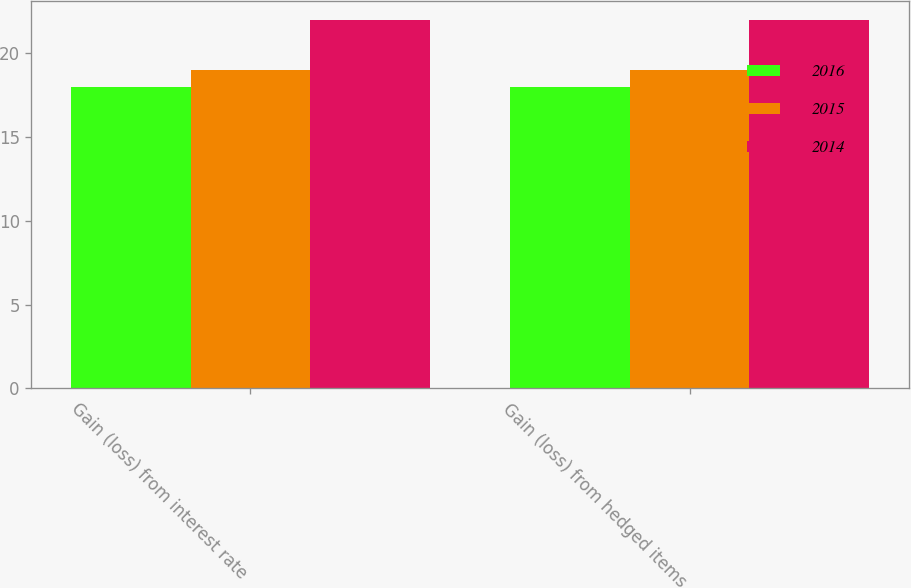Convert chart to OTSL. <chart><loc_0><loc_0><loc_500><loc_500><stacked_bar_chart><ecel><fcel>Gain (loss) from interest rate<fcel>Gain (loss) from hedged items<nl><fcel>2016<fcel>18<fcel>18<nl><fcel>2015<fcel>19<fcel>19<nl><fcel>2014<fcel>22<fcel>22<nl></chart> 